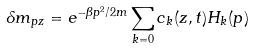Convert formula to latex. <formula><loc_0><loc_0><loc_500><loc_500>\delta m _ { p z } = e ^ { - \beta p ^ { 2 } / 2 m } \sum _ { k = 0 } c _ { k } ( z , t ) H _ { k } ( p )</formula> 